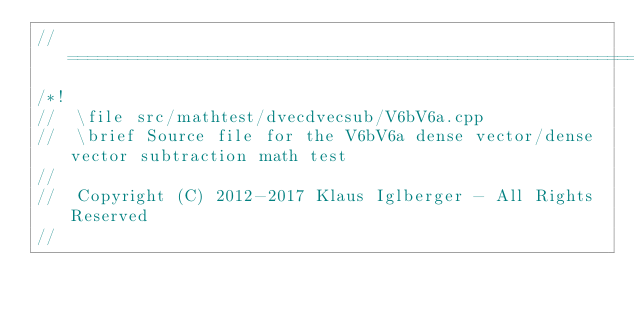<code> <loc_0><loc_0><loc_500><loc_500><_C++_>//=================================================================================================
/*!
//  \file src/mathtest/dvecdvecsub/V6bV6a.cpp
//  \brief Source file for the V6bV6a dense vector/dense vector subtraction math test
//
//  Copyright (C) 2012-2017 Klaus Iglberger - All Rights Reserved
//</code> 